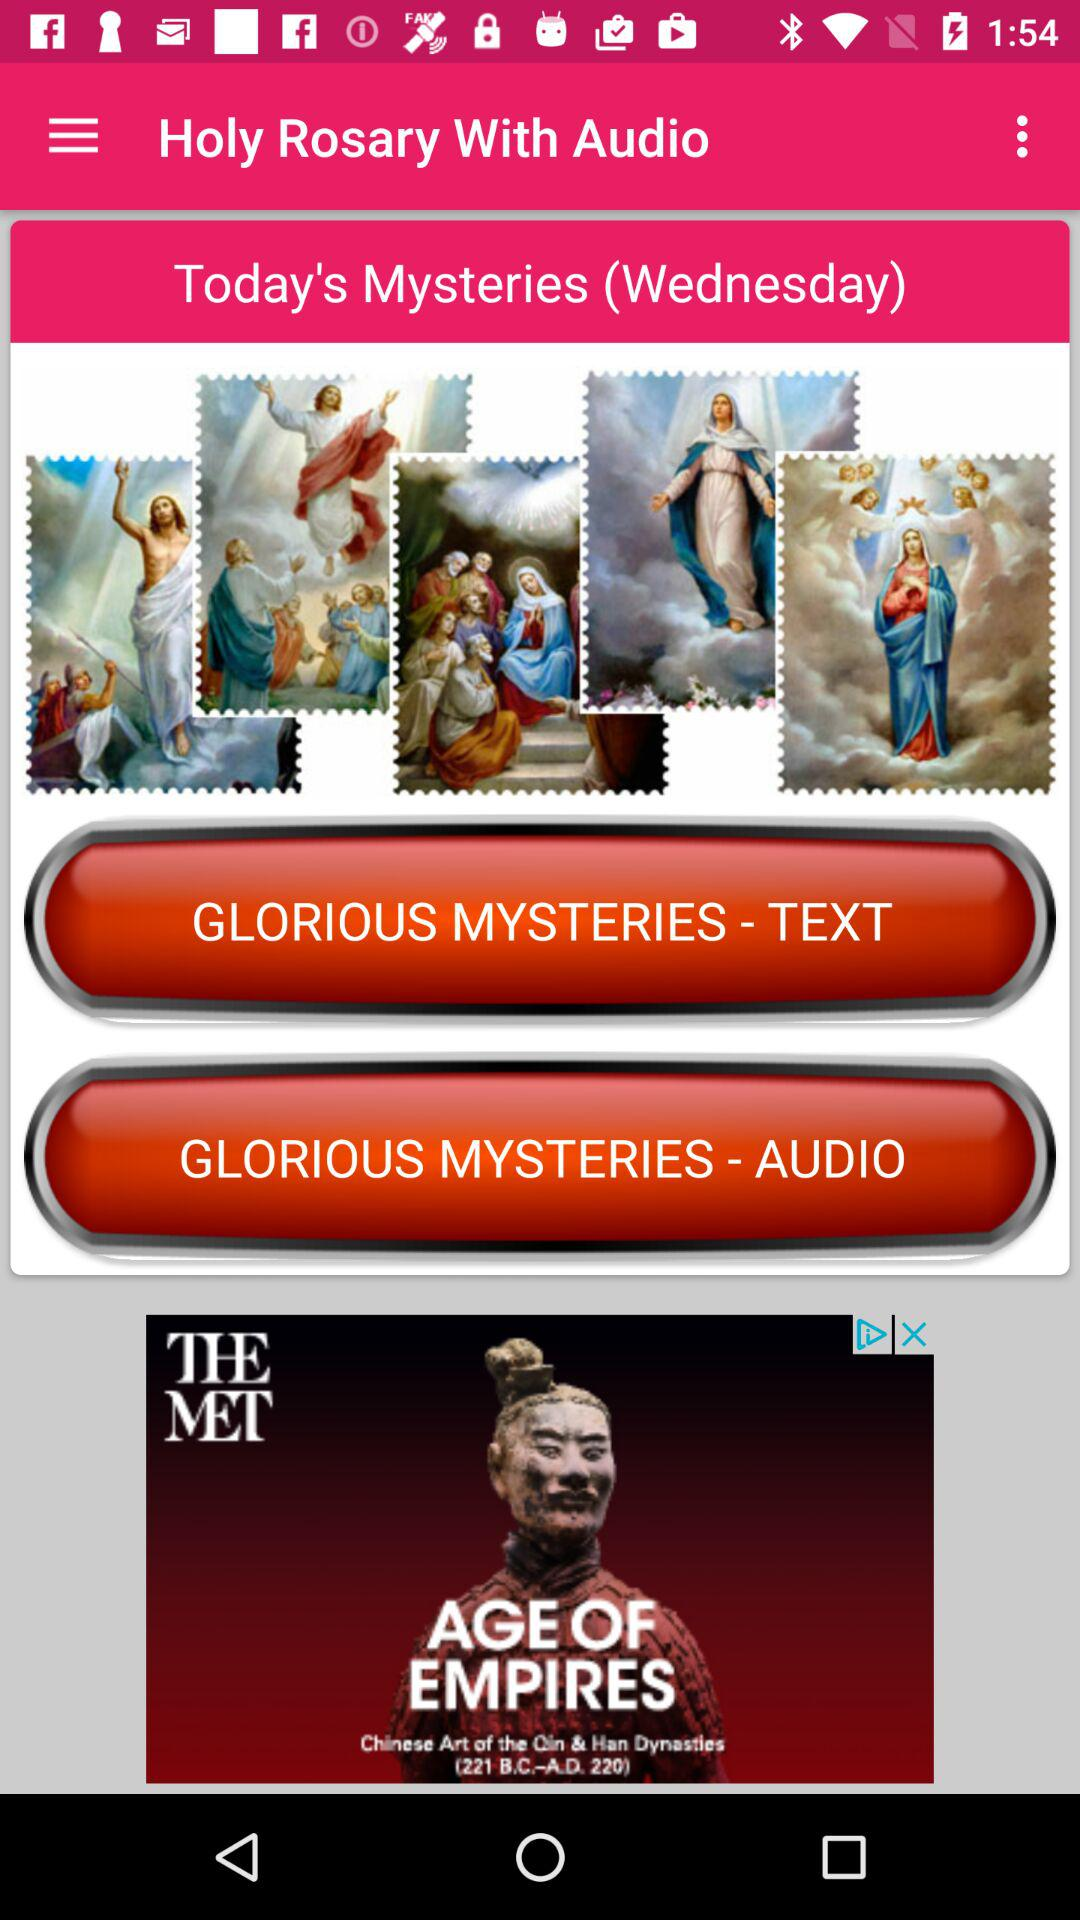Which day is it today?
Answer the question using a single word or phrase. Today is Wednesday. 